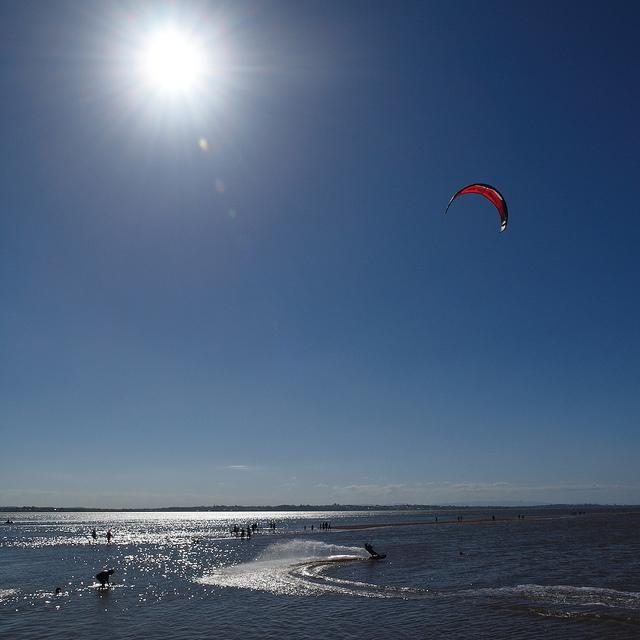What is the person with the kite doing?

Choices:
A) flying
B) kite flying
C) sailing
D) kitesurfing kitesurfing 